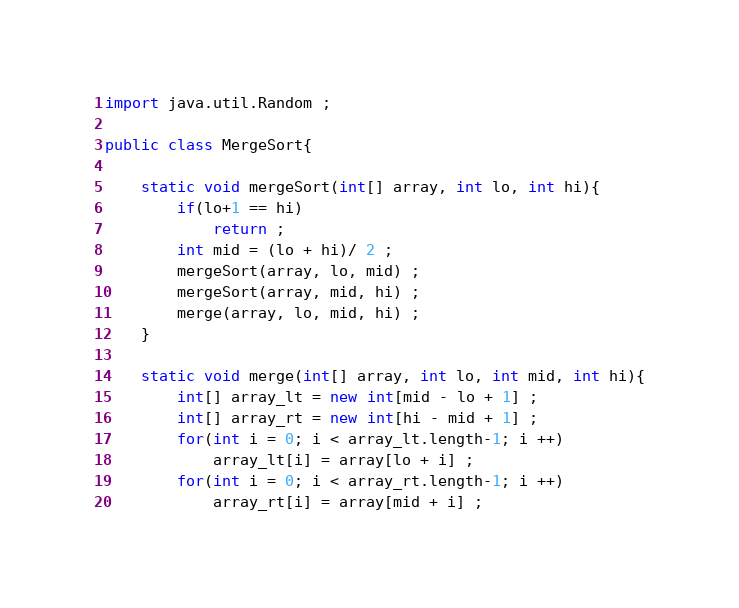<code> <loc_0><loc_0><loc_500><loc_500><_Java_>import java.util.Random ;

public class MergeSort{

    static void mergeSort(int[] array, int lo, int hi){
        if(lo+1 == hi)
            return ;
        int mid = (lo + hi)/ 2 ;
        mergeSort(array, lo, mid) ;
        mergeSort(array, mid, hi) ;
        merge(array, lo, mid, hi) ;
    }

    static void merge(int[] array, int lo, int mid, int hi){
        int[] array_lt = new int[mid - lo + 1] ;
        int[] array_rt = new int[hi - mid + 1] ;
        for(int i = 0; i < array_lt.length-1; i ++)
            array_lt[i] = array[lo + i] ;
        for(int i = 0; i < array_rt.length-1; i ++)
            array_rt[i] = array[mid + i] ;</code> 